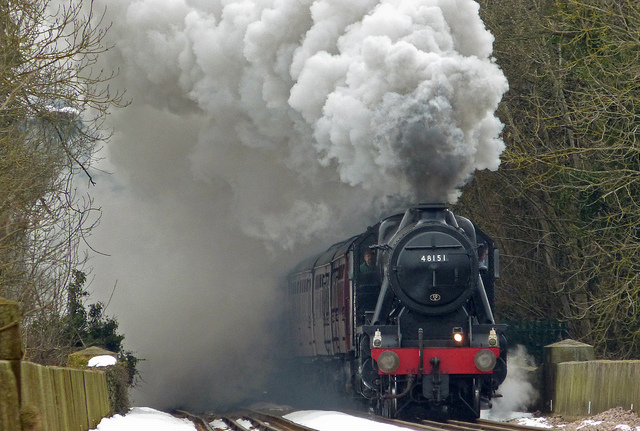Please identify all text content in this image. 48151 